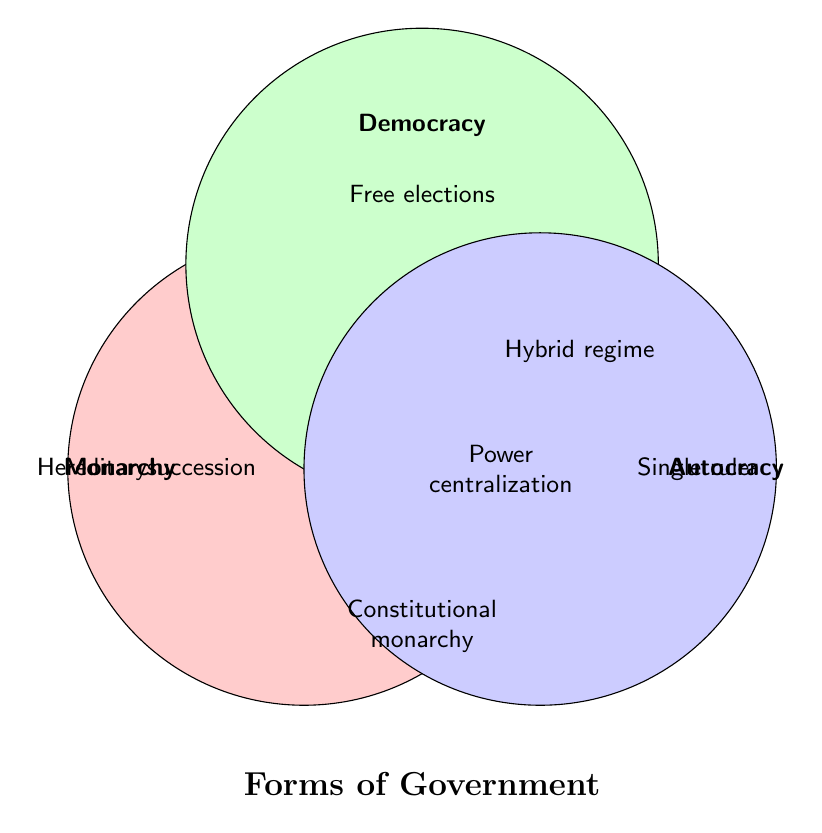What is the main theme of the Venn Diagram? The title at the bottom of the diagram indicates that it represents forms of government.
Answer: Forms of Government What feature is shared among monarchy, democracy, and autocracy? The center of the diagram where all three circles overlap indicates the shared features.
Answer: Power centralization, State institutions Which form of government is associated with hereditary succession? Look in the section labeled Monarchy.
Answer: Monarchy In which section does "Constitutional monarchy" appear? It appears in the overlapping section between Monarchy and Democracy.
Answer: Between Monarchy and Democracy How many features are exclusive to autocracy? The section labeled Autocracy contains two exclusive features.
Answer: Two Which form of government includes "Free elections"? This feature is found in the Democracy section.
Answer: Democracy Where would you find the feature "Hybrid regime"? It is located in the overlapping region between Democracy and Autocracy.
Answer: Between Democracy and Autocracy What is the feature listed in the overlapping area between Monarchy and Autocracy? The overlapping section between Monarchy and Autocracy shows this feature.
Answer: Absolute monarchy Which section does "Limited opposition" fall under? Look in the section labeled Autocracy.
Answer: Autocracy 